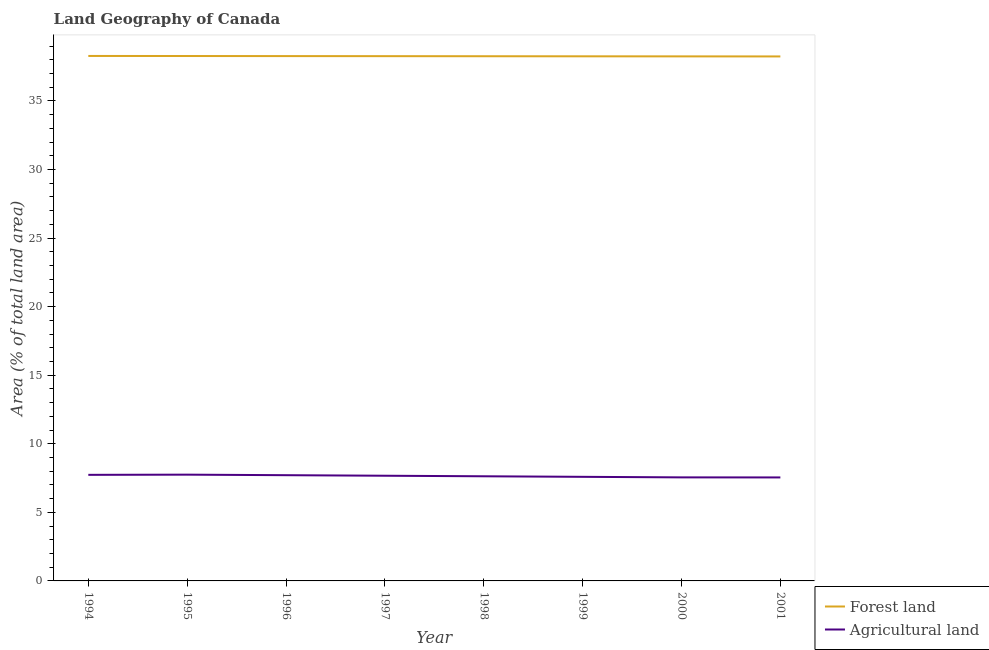How many different coloured lines are there?
Make the answer very short. 2. Does the line corresponding to percentage of land area under agriculture intersect with the line corresponding to percentage of land area under forests?
Your answer should be compact. No. What is the percentage of land area under forests in 1996?
Your answer should be very brief. 38.27. Across all years, what is the maximum percentage of land area under forests?
Your answer should be very brief. 38.28. Across all years, what is the minimum percentage of land area under forests?
Offer a terse response. 38.24. In which year was the percentage of land area under forests maximum?
Provide a succinct answer. 1994. What is the total percentage of land area under forests in the graph?
Provide a short and direct response. 306.08. What is the difference between the percentage of land area under forests in 1994 and that in 1998?
Your answer should be very brief. 0.02. What is the difference between the percentage of land area under forests in 1999 and the percentage of land area under agriculture in 2001?
Offer a terse response. 30.71. What is the average percentage of land area under forests per year?
Ensure brevity in your answer.  38.26. In the year 1999, what is the difference between the percentage of land area under agriculture and percentage of land area under forests?
Your response must be concise. -30.66. What is the ratio of the percentage of land area under agriculture in 1994 to that in 1997?
Offer a very short reply. 1.01. Is the percentage of land area under agriculture in 1997 less than that in 2001?
Your answer should be very brief. No. Is the difference between the percentage of land area under agriculture in 1999 and 2001 greater than the difference between the percentage of land area under forests in 1999 and 2001?
Give a very brief answer. Yes. What is the difference between the highest and the second highest percentage of land area under forests?
Your response must be concise. 0.01. What is the difference between the highest and the lowest percentage of land area under forests?
Keep it short and to the point. 0.04. In how many years, is the percentage of land area under agriculture greater than the average percentage of land area under agriculture taken over all years?
Make the answer very short. 4. Is the sum of the percentage of land area under forests in 1998 and 2001 greater than the maximum percentage of land area under agriculture across all years?
Provide a short and direct response. Yes. How many lines are there?
Ensure brevity in your answer.  2. What is the difference between two consecutive major ticks on the Y-axis?
Give a very brief answer. 5. Does the graph contain any zero values?
Your response must be concise. No. Does the graph contain grids?
Offer a terse response. No. Where does the legend appear in the graph?
Your response must be concise. Bottom right. How many legend labels are there?
Provide a succinct answer. 2. What is the title of the graph?
Provide a short and direct response. Land Geography of Canada. What is the label or title of the X-axis?
Your answer should be very brief. Year. What is the label or title of the Y-axis?
Ensure brevity in your answer.  Area (% of total land area). What is the Area (% of total land area) in Forest land in 1994?
Ensure brevity in your answer.  38.28. What is the Area (% of total land area) in Agricultural land in 1994?
Offer a terse response. 7.73. What is the Area (% of total land area) of Forest land in 1995?
Your response must be concise. 38.27. What is the Area (% of total land area) in Agricultural land in 1995?
Offer a terse response. 7.75. What is the Area (% of total land area) of Forest land in 1996?
Provide a succinct answer. 38.27. What is the Area (% of total land area) of Agricultural land in 1996?
Offer a very short reply. 7.71. What is the Area (% of total land area) in Forest land in 1997?
Offer a terse response. 38.26. What is the Area (% of total land area) in Agricultural land in 1997?
Provide a short and direct response. 7.67. What is the Area (% of total land area) in Forest land in 1998?
Provide a succinct answer. 38.26. What is the Area (% of total land area) of Agricultural land in 1998?
Offer a terse response. 7.63. What is the Area (% of total land area) of Forest land in 1999?
Your answer should be compact. 38.25. What is the Area (% of total land area) in Agricultural land in 1999?
Your answer should be compact. 7.59. What is the Area (% of total land area) of Forest land in 2000?
Give a very brief answer. 38.25. What is the Area (% of total land area) in Agricultural land in 2000?
Give a very brief answer. 7.55. What is the Area (% of total land area) in Forest land in 2001?
Your answer should be very brief. 38.24. What is the Area (% of total land area) of Agricultural land in 2001?
Your answer should be very brief. 7.55. Across all years, what is the maximum Area (% of total land area) of Forest land?
Provide a short and direct response. 38.28. Across all years, what is the maximum Area (% of total land area) in Agricultural land?
Give a very brief answer. 7.75. Across all years, what is the minimum Area (% of total land area) in Forest land?
Ensure brevity in your answer.  38.24. Across all years, what is the minimum Area (% of total land area) of Agricultural land?
Keep it short and to the point. 7.55. What is the total Area (% of total land area) in Forest land in the graph?
Give a very brief answer. 306.08. What is the total Area (% of total land area) in Agricultural land in the graph?
Your response must be concise. 61.18. What is the difference between the Area (% of total land area) in Forest land in 1994 and that in 1995?
Provide a short and direct response. 0.01. What is the difference between the Area (% of total land area) of Agricultural land in 1994 and that in 1995?
Give a very brief answer. -0.01. What is the difference between the Area (% of total land area) in Forest land in 1994 and that in 1996?
Provide a succinct answer. 0.01. What is the difference between the Area (% of total land area) of Agricultural land in 1994 and that in 1996?
Offer a terse response. 0.03. What is the difference between the Area (% of total land area) of Forest land in 1994 and that in 1997?
Give a very brief answer. 0.02. What is the difference between the Area (% of total land area) of Agricultural land in 1994 and that in 1997?
Provide a short and direct response. 0.07. What is the difference between the Area (% of total land area) in Forest land in 1994 and that in 1998?
Give a very brief answer. 0.02. What is the difference between the Area (% of total land area) in Agricultural land in 1994 and that in 1998?
Your response must be concise. 0.1. What is the difference between the Area (% of total land area) of Forest land in 1994 and that in 1999?
Your answer should be very brief. 0.03. What is the difference between the Area (% of total land area) in Agricultural land in 1994 and that in 1999?
Provide a short and direct response. 0.14. What is the difference between the Area (% of total land area) in Forest land in 1994 and that in 2000?
Ensure brevity in your answer.  0.03. What is the difference between the Area (% of total land area) of Agricultural land in 1994 and that in 2000?
Your answer should be very brief. 0.18. What is the difference between the Area (% of total land area) in Forest land in 1994 and that in 2001?
Keep it short and to the point. 0.04. What is the difference between the Area (% of total land area) of Agricultural land in 1994 and that in 2001?
Give a very brief answer. 0.19. What is the difference between the Area (% of total land area) in Forest land in 1995 and that in 1996?
Your answer should be compact. 0.01. What is the difference between the Area (% of total land area) of Agricultural land in 1995 and that in 1996?
Your response must be concise. 0.04. What is the difference between the Area (% of total land area) of Forest land in 1995 and that in 1997?
Your answer should be very brief. 0.01. What is the difference between the Area (% of total land area) in Agricultural land in 1995 and that in 1997?
Offer a very short reply. 0.08. What is the difference between the Area (% of total land area) in Forest land in 1995 and that in 1998?
Ensure brevity in your answer.  0.02. What is the difference between the Area (% of total land area) in Agricultural land in 1995 and that in 1998?
Keep it short and to the point. 0.12. What is the difference between the Area (% of total land area) of Forest land in 1995 and that in 1999?
Ensure brevity in your answer.  0.02. What is the difference between the Area (% of total land area) of Agricultural land in 1995 and that in 1999?
Provide a short and direct response. 0.16. What is the difference between the Area (% of total land area) in Forest land in 1995 and that in 2000?
Provide a succinct answer. 0.03. What is the difference between the Area (% of total land area) of Agricultural land in 1995 and that in 2000?
Provide a succinct answer. 0.2. What is the difference between the Area (% of total land area) of Forest land in 1995 and that in 2001?
Keep it short and to the point. 0.03. What is the difference between the Area (% of total land area) of Agricultural land in 1995 and that in 2001?
Ensure brevity in your answer.  0.2. What is the difference between the Area (% of total land area) in Forest land in 1996 and that in 1997?
Your answer should be compact. 0.01. What is the difference between the Area (% of total land area) of Agricultural land in 1996 and that in 1997?
Offer a very short reply. 0.04. What is the difference between the Area (% of total land area) in Forest land in 1996 and that in 1998?
Your answer should be very brief. 0.01. What is the difference between the Area (% of total land area) of Agricultural land in 1996 and that in 1998?
Offer a very short reply. 0.08. What is the difference between the Area (% of total land area) of Forest land in 1996 and that in 1999?
Your answer should be compact. 0.02. What is the difference between the Area (% of total land area) in Agricultural land in 1996 and that in 1999?
Give a very brief answer. 0.12. What is the difference between the Area (% of total land area) in Forest land in 1996 and that in 2000?
Give a very brief answer. 0.02. What is the difference between the Area (% of total land area) of Agricultural land in 1996 and that in 2000?
Your answer should be very brief. 0.16. What is the difference between the Area (% of total land area) of Forest land in 1996 and that in 2001?
Your answer should be compact. 0.03. What is the difference between the Area (% of total land area) of Agricultural land in 1996 and that in 2001?
Your answer should be very brief. 0.16. What is the difference between the Area (% of total land area) of Forest land in 1997 and that in 1998?
Your response must be concise. 0.01. What is the difference between the Area (% of total land area) of Agricultural land in 1997 and that in 1998?
Make the answer very short. 0.04. What is the difference between the Area (% of total land area) of Forest land in 1997 and that in 1999?
Your answer should be compact. 0.01. What is the difference between the Area (% of total land area) of Agricultural land in 1997 and that in 1999?
Keep it short and to the point. 0.08. What is the difference between the Area (% of total land area) in Forest land in 1997 and that in 2000?
Provide a succinct answer. 0.02. What is the difference between the Area (% of total land area) in Agricultural land in 1997 and that in 2000?
Your response must be concise. 0.12. What is the difference between the Area (% of total land area) in Forest land in 1997 and that in 2001?
Your answer should be very brief. 0.02. What is the difference between the Area (% of total land area) of Agricultural land in 1997 and that in 2001?
Make the answer very short. 0.12. What is the difference between the Area (% of total land area) of Forest land in 1998 and that in 1999?
Keep it short and to the point. 0.01. What is the difference between the Area (% of total land area) of Agricultural land in 1998 and that in 1999?
Your answer should be very brief. 0.04. What is the difference between the Area (% of total land area) of Forest land in 1998 and that in 2000?
Provide a succinct answer. 0.01. What is the difference between the Area (% of total land area) in Agricultural land in 1998 and that in 2000?
Offer a terse response. 0.08. What is the difference between the Area (% of total land area) in Forest land in 1998 and that in 2001?
Offer a terse response. 0.02. What is the difference between the Area (% of total land area) of Agricultural land in 1998 and that in 2001?
Keep it short and to the point. 0.08. What is the difference between the Area (% of total land area) of Forest land in 1999 and that in 2000?
Offer a very short reply. 0.01. What is the difference between the Area (% of total land area) in Agricultural land in 1999 and that in 2000?
Ensure brevity in your answer.  0.04. What is the difference between the Area (% of total land area) of Forest land in 1999 and that in 2001?
Keep it short and to the point. 0.01. What is the difference between the Area (% of total land area) of Agricultural land in 1999 and that in 2001?
Keep it short and to the point. 0.04. What is the difference between the Area (% of total land area) in Forest land in 2000 and that in 2001?
Keep it short and to the point. 0.01. What is the difference between the Area (% of total land area) in Agricultural land in 2000 and that in 2001?
Provide a short and direct response. 0.01. What is the difference between the Area (% of total land area) in Forest land in 1994 and the Area (% of total land area) in Agricultural land in 1995?
Ensure brevity in your answer.  30.53. What is the difference between the Area (% of total land area) in Forest land in 1994 and the Area (% of total land area) in Agricultural land in 1996?
Keep it short and to the point. 30.57. What is the difference between the Area (% of total land area) in Forest land in 1994 and the Area (% of total land area) in Agricultural land in 1997?
Provide a succinct answer. 30.61. What is the difference between the Area (% of total land area) of Forest land in 1994 and the Area (% of total land area) of Agricultural land in 1998?
Give a very brief answer. 30.65. What is the difference between the Area (% of total land area) in Forest land in 1994 and the Area (% of total land area) in Agricultural land in 1999?
Offer a terse response. 30.69. What is the difference between the Area (% of total land area) of Forest land in 1994 and the Area (% of total land area) of Agricultural land in 2000?
Your response must be concise. 30.73. What is the difference between the Area (% of total land area) of Forest land in 1994 and the Area (% of total land area) of Agricultural land in 2001?
Your answer should be compact. 30.73. What is the difference between the Area (% of total land area) in Forest land in 1995 and the Area (% of total land area) in Agricultural land in 1996?
Provide a succinct answer. 30.56. What is the difference between the Area (% of total land area) of Forest land in 1995 and the Area (% of total land area) of Agricultural land in 1997?
Provide a succinct answer. 30.6. What is the difference between the Area (% of total land area) of Forest land in 1995 and the Area (% of total land area) of Agricultural land in 1998?
Your answer should be very brief. 30.64. What is the difference between the Area (% of total land area) in Forest land in 1995 and the Area (% of total land area) in Agricultural land in 1999?
Make the answer very short. 30.68. What is the difference between the Area (% of total land area) of Forest land in 1995 and the Area (% of total land area) of Agricultural land in 2000?
Make the answer very short. 30.72. What is the difference between the Area (% of total land area) in Forest land in 1995 and the Area (% of total land area) in Agricultural land in 2001?
Your answer should be very brief. 30.73. What is the difference between the Area (% of total land area) in Forest land in 1996 and the Area (% of total land area) in Agricultural land in 1997?
Offer a terse response. 30.6. What is the difference between the Area (% of total land area) of Forest land in 1996 and the Area (% of total land area) of Agricultural land in 1998?
Your response must be concise. 30.64. What is the difference between the Area (% of total land area) in Forest land in 1996 and the Area (% of total land area) in Agricultural land in 1999?
Offer a terse response. 30.68. What is the difference between the Area (% of total land area) of Forest land in 1996 and the Area (% of total land area) of Agricultural land in 2000?
Give a very brief answer. 30.72. What is the difference between the Area (% of total land area) of Forest land in 1996 and the Area (% of total land area) of Agricultural land in 2001?
Your response must be concise. 30.72. What is the difference between the Area (% of total land area) in Forest land in 1997 and the Area (% of total land area) in Agricultural land in 1998?
Your answer should be very brief. 30.63. What is the difference between the Area (% of total land area) in Forest land in 1997 and the Area (% of total land area) in Agricultural land in 1999?
Provide a short and direct response. 30.67. What is the difference between the Area (% of total land area) in Forest land in 1997 and the Area (% of total land area) in Agricultural land in 2000?
Make the answer very short. 30.71. What is the difference between the Area (% of total land area) in Forest land in 1997 and the Area (% of total land area) in Agricultural land in 2001?
Make the answer very short. 30.72. What is the difference between the Area (% of total land area) in Forest land in 1998 and the Area (% of total land area) in Agricultural land in 1999?
Offer a terse response. 30.67. What is the difference between the Area (% of total land area) of Forest land in 1998 and the Area (% of total land area) of Agricultural land in 2000?
Offer a very short reply. 30.71. What is the difference between the Area (% of total land area) in Forest land in 1998 and the Area (% of total land area) in Agricultural land in 2001?
Make the answer very short. 30.71. What is the difference between the Area (% of total land area) of Forest land in 1999 and the Area (% of total land area) of Agricultural land in 2000?
Your answer should be compact. 30.7. What is the difference between the Area (% of total land area) in Forest land in 1999 and the Area (% of total land area) in Agricultural land in 2001?
Provide a short and direct response. 30.71. What is the difference between the Area (% of total land area) of Forest land in 2000 and the Area (% of total land area) of Agricultural land in 2001?
Provide a succinct answer. 30.7. What is the average Area (% of total land area) in Forest land per year?
Your answer should be very brief. 38.26. What is the average Area (% of total land area) in Agricultural land per year?
Give a very brief answer. 7.65. In the year 1994, what is the difference between the Area (% of total land area) of Forest land and Area (% of total land area) of Agricultural land?
Your answer should be compact. 30.54. In the year 1995, what is the difference between the Area (% of total land area) in Forest land and Area (% of total land area) in Agricultural land?
Your response must be concise. 30.52. In the year 1996, what is the difference between the Area (% of total land area) in Forest land and Area (% of total land area) in Agricultural land?
Your response must be concise. 30.56. In the year 1997, what is the difference between the Area (% of total land area) of Forest land and Area (% of total land area) of Agricultural land?
Make the answer very short. 30.59. In the year 1998, what is the difference between the Area (% of total land area) of Forest land and Area (% of total land area) of Agricultural land?
Keep it short and to the point. 30.63. In the year 1999, what is the difference between the Area (% of total land area) in Forest land and Area (% of total land area) in Agricultural land?
Offer a terse response. 30.66. In the year 2000, what is the difference between the Area (% of total land area) of Forest land and Area (% of total land area) of Agricultural land?
Your answer should be very brief. 30.7. In the year 2001, what is the difference between the Area (% of total land area) of Forest land and Area (% of total land area) of Agricultural land?
Provide a short and direct response. 30.7. What is the ratio of the Area (% of total land area) in Forest land in 1994 to that in 1995?
Provide a short and direct response. 1. What is the ratio of the Area (% of total land area) of Forest land in 1994 to that in 1997?
Offer a very short reply. 1. What is the ratio of the Area (% of total land area) of Agricultural land in 1994 to that in 1997?
Ensure brevity in your answer.  1.01. What is the ratio of the Area (% of total land area) of Agricultural land in 1994 to that in 1998?
Ensure brevity in your answer.  1.01. What is the ratio of the Area (% of total land area) in Forest land in 1994 to that in 1999?
Your answer should be very brief. 1. What is the ratio of the Area (% of total land area) of Agricultural land in 1994 to that in 1999?
Provide a short and direct response. 1.02. What is the ratio of the Area (% of total land area) in Forest land in 1994 to that in 2000?
Provide a succinct answer. 1. What is the ratio of the Area (% of total land area) of Agricultural land in 1994 to that in 2000?
Give a very brief answer. 1.02. What is the ratio of the Area (% of total land area) in Agricultural land in 1994 to that in 2001?
Keep it short and to the point. 1.03. What is the ratio of the Area (% of total land area) of Forest land in 1995 to that in 1997?
Your answer should be compact. 1. What is the ratio of the Area (% of total land area) in Agricultural land in 1995 to that in 1997?
Provide a short and direct response. 1.01. What is the ratio of the Area (% of total land area) in Forest land in 1995 to that in 1998?
Provide a succinct answer. 1. What is the ratio of the Area (% of total land area) in Agricultural land in 1995 to that in 1998?
Your answer should be very brief. 1.02. What is the ratio of the Area (% of total land area) in Agricultural land in 1995 to that in 1999?
Make the answer very short. 1.02. What is the ratio of the Area (% of total land area) in Agricultural land in 1995 to that in 2000?
Your response must be concise. 1.03. What is the ratio of the Area (% of total land area) of Agricultural land in 1995 to that in 2001?
Provide a succinct answer. 1.03. What is the ratio of the Area (% of total land area) in Forest land in 1996 to that in 1997?
Provide a short and direct response. 1. What is the ratio of the Area (% of total land area) of Forest land in 1996 to that in 1998?
Ensure brevity in your answer.  1. What is the ratio of the Area (% of total land area) in Agricultural land in 1996 to that in 1998?
Offer a terse response. 1.01. What is the ratio of the Area (% of total land area) of Agricultural land in 1996 to that in 1999?
Give a very brief answer. 1.02. What is the ratio of the Area (% of total land area) in Forest land in 1996 to that in 2000?
Keep it short and to the point. 1. What is the ratio of the Area (% of total land area) in Forest land in 1996 to that in 2001?
Offer a very short reply. 1. What is the ratio of the Area (% of total land area) of Agricultural land in 1996 to that in 2001?
Your answer should be very brief. 1.02. What is the ratio of the Area (% of total land area) of Agricultural land in 1997 to that in 1998?
Keep it short and to the point. 1.01. What is the ratio of the Area (% of total land area) of Forest land in 1997 to that in 1999?
Ensure brevity in your answer.  1. What is the ratio of the Area (% of total land area) in Agricultural land in 1997 to that in 1999?
Give a very brief answer. 1.01. What is the ratio of the Area (% of total land area) in Forest land in 1997 to that in 2000?
Give a very brief answer. 1. What is the ratio of the Area (% of total land area) of Agricultural land in 1997 to that in 2000?
Provide a short and direct response. 1.02. What is the ratio of the Area (% of total land area) in Agricultural land in 1997 to that in 2001?
Provide a succinct answer. 1.02. What is the ratio of the Area (% of total land area) in Forest land in 1998 to that in 1999?
Give a very brief answer. 1. What is the ratio of the Area (% of total land area) in Agricultural land in 1998 to that in 2000?
Your answer should be very brief. 1.01. What is the ratio of the Area (% of total land area) in Forest land in 1998 to that in 2001?
Ensure brevity in your answer.  1. What is the ratio of the Area (% of total land area) in Agricultural land in 1998 to that in 2001?
Your answer should be very brief. 1.01. What is the ratio of the Area (% of total land area) of Forest land in 1999 to that in 2000?
Keep it short and to the point. 1. What is the ratio of the Area (% of total land area) in Agricultural land in 1999 to that in 2000?
Offer a terse response. 1.01. What is the ratio of the Area (% of total land area) in Agricultural land in 1999 to that in 2001?
Keep it short and to the point. 1.01. What is the ratio of the Area (% of total land area) of Agricultural land in 2000 to that in 2001?
Make the answer very short. 1. What is the difference between the highest and the second highest Area (% of total land area) in Forest land?
Give a very brief answer. 0.01. What is the difference between the highest and the second highest Area (% of total land area) of Agricultural land?
Your response must be concise. 0.01. What is the difference between the highest and the lowest Area (% of total land area) in Forest land?
Your answer should be compact. 0.04. What is the difference between the highest and the lowest Area (% of total land area) of Agricultural land?
Keep it short and to the point. 0.2. 